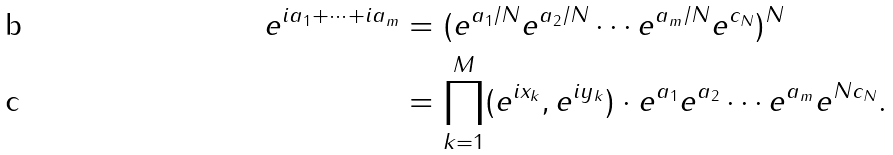<formula> <loc_0><loc_0><loc_500><loc_500>e ^ { i a _ { 1 } + \dots + i a _ { m } } & = ( e ^ { a _ { 1 } / N } e ^ { a _ { 2 } / N } \cdots e ^ { a _ { m } / N } e ^ { c _ { N } } ) ^ { N } \\ & = \prod _ { k = 1 } ^ { M } ( e ^ { i x _ { k } } , e ^ { i y _ { k } } ) \cdot e ^ { a _ { 1 } } e ^ { a _ { 2 } } \cdots e ^ { a _ { m } } e ^ { N c _ { N } } .</formula> 